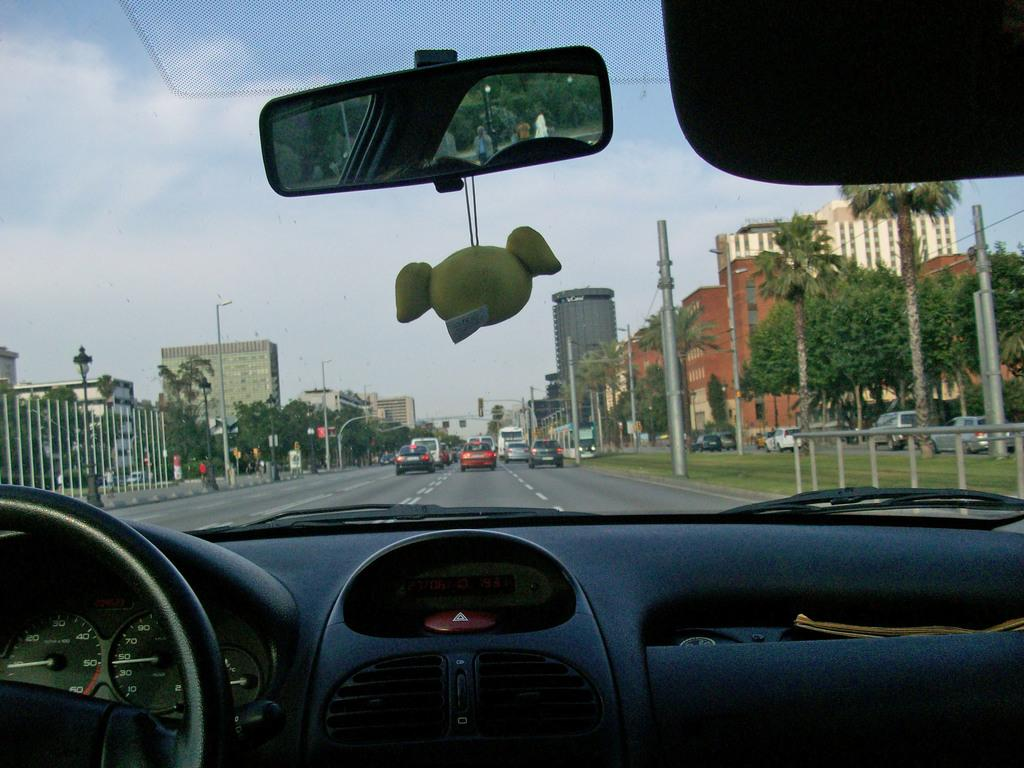What is the perspective of the image? The image is taken from inside a car. What can be seen behind the car? There is a road behind the car, with vehicles on it. What is the natural environment visible near the road? Grass is visible near the road. What structures can be seen along the road? There are poles along the road. What is visible in the background of the image? There are buildings and trees in the background. What type of line is being used to hold the butter in the image? There is no butter or line present in the image. 